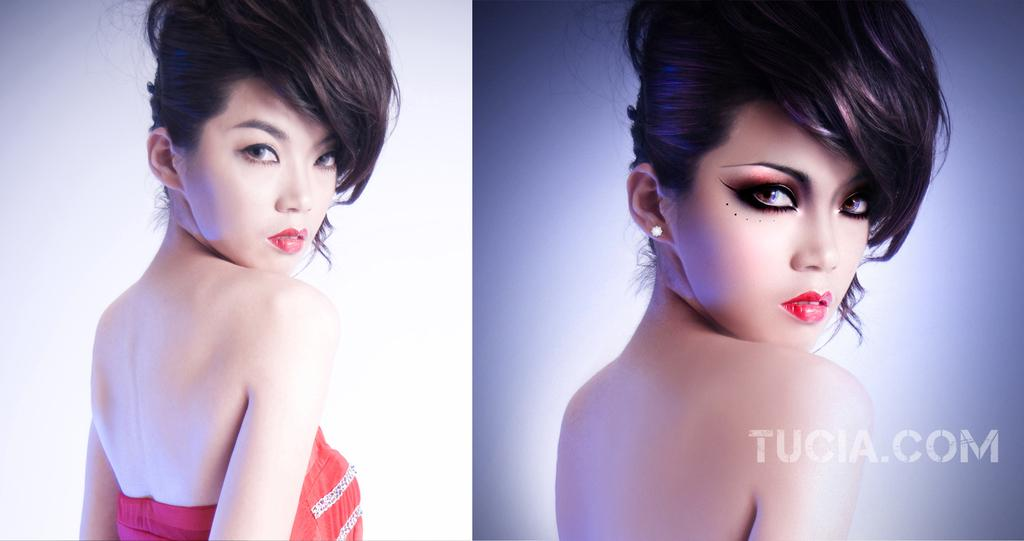What type of artwork is the image? The image is a collage. Can you describe any people in the image? There is a woman in the image. What type of instrument does the woman play in the image? There is no instrument present in the image, as it is a collage and not a scene of someone playing an instrument. 